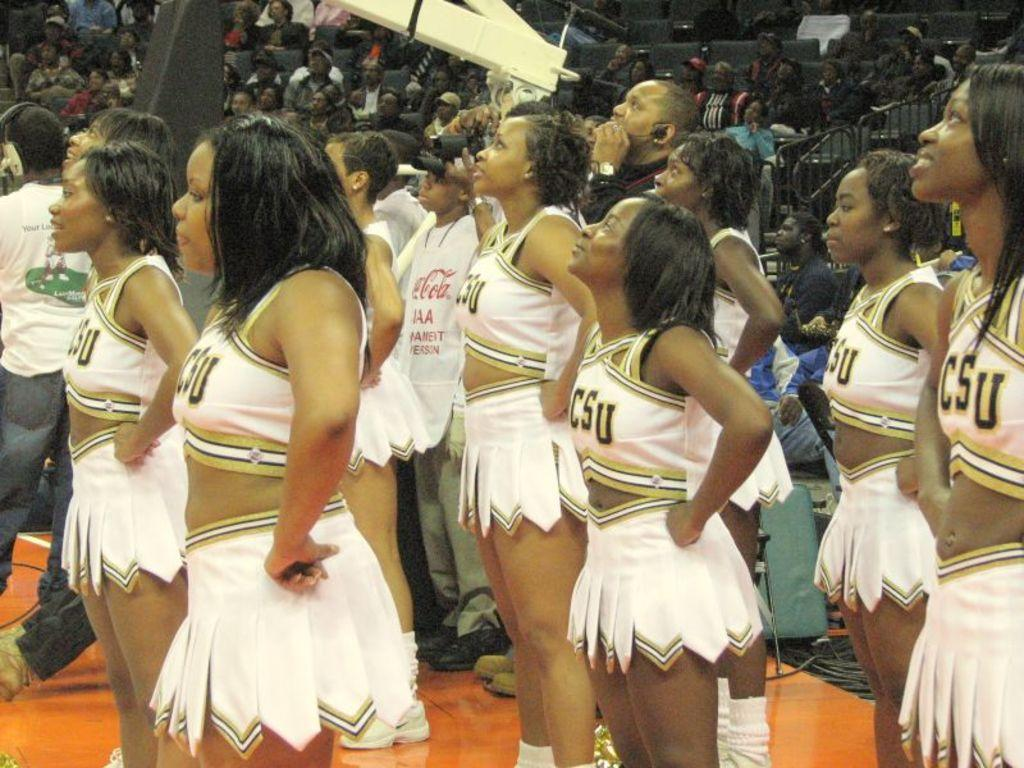<image>
Create a compact narrative representing the image presented. A group of cheerleaders wearing CSU on their uniforms stand on the court. 